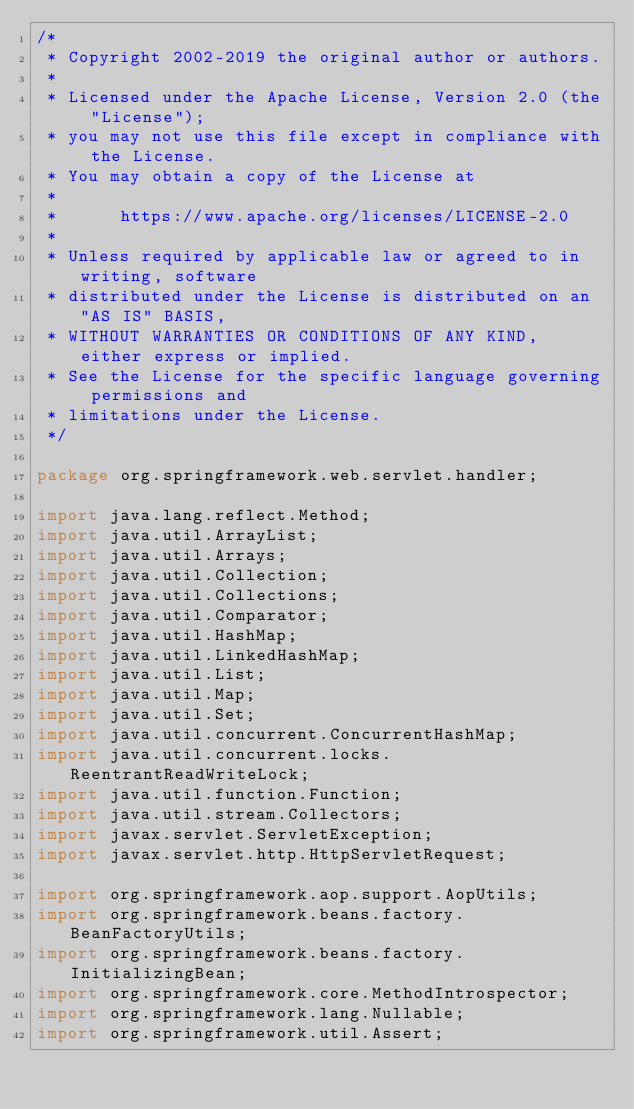Convert code to text. <code><loc_0><loc_0><loc_500><loc_500><_Java_>/*
 * Copyright 2002-2019 the original author or authors.
 *
 * Licensed under the Apache License, Version 2.0 (the "License");
 * you may not use this file except in compliance with the License.
 * You may obtain a copy of the License at
 *
 *      https://www.apache.org/licenses/LICENSE-2.0
 *
 * Unless required by applicable law or agreed to in writing, software
 * distributed under the License is distributed on an "AS IS" BASIS,
 * WITHOUT WARRANTIES OR CONDITIONS OF ANY KIND, either express or implied.
 * See the License for the specific language governing permissions and
 * limitations under the License.
 */

package org.springframework.web.servlet.handler;

import java.lang.reflect.Method;
import java.util.ArrayList;
import java.util.Arrays;
import java.util.Collection;
import java.util.Collections;
import java.util.Comparator;
import java.util.HashMap;
import java.util.LinkedHashMap;
import java.util.List;
import java.util.Map;
import java.util.Set;
import java.util.concurrent.ConcurrentHashMap;
import java.util.concurrent.locks.ReentrantReadWriteLock;
import java.util.function.Function;
import java.util.stream.Collectors;
import javax.servlet.ServletException;
import javax.servlet.http.HttpServletRequest;

import org.springframework.aop.support.AopUtils;
import org.springframework.beans.factory.BeanFactoryUtils;
import org.springframework.beans.factory.InitializingBean;
import org.springframework.core.MethodIntrospector;
import org.springframework.lang.Nullable;
import org.springframework.util.Assert;</code> 